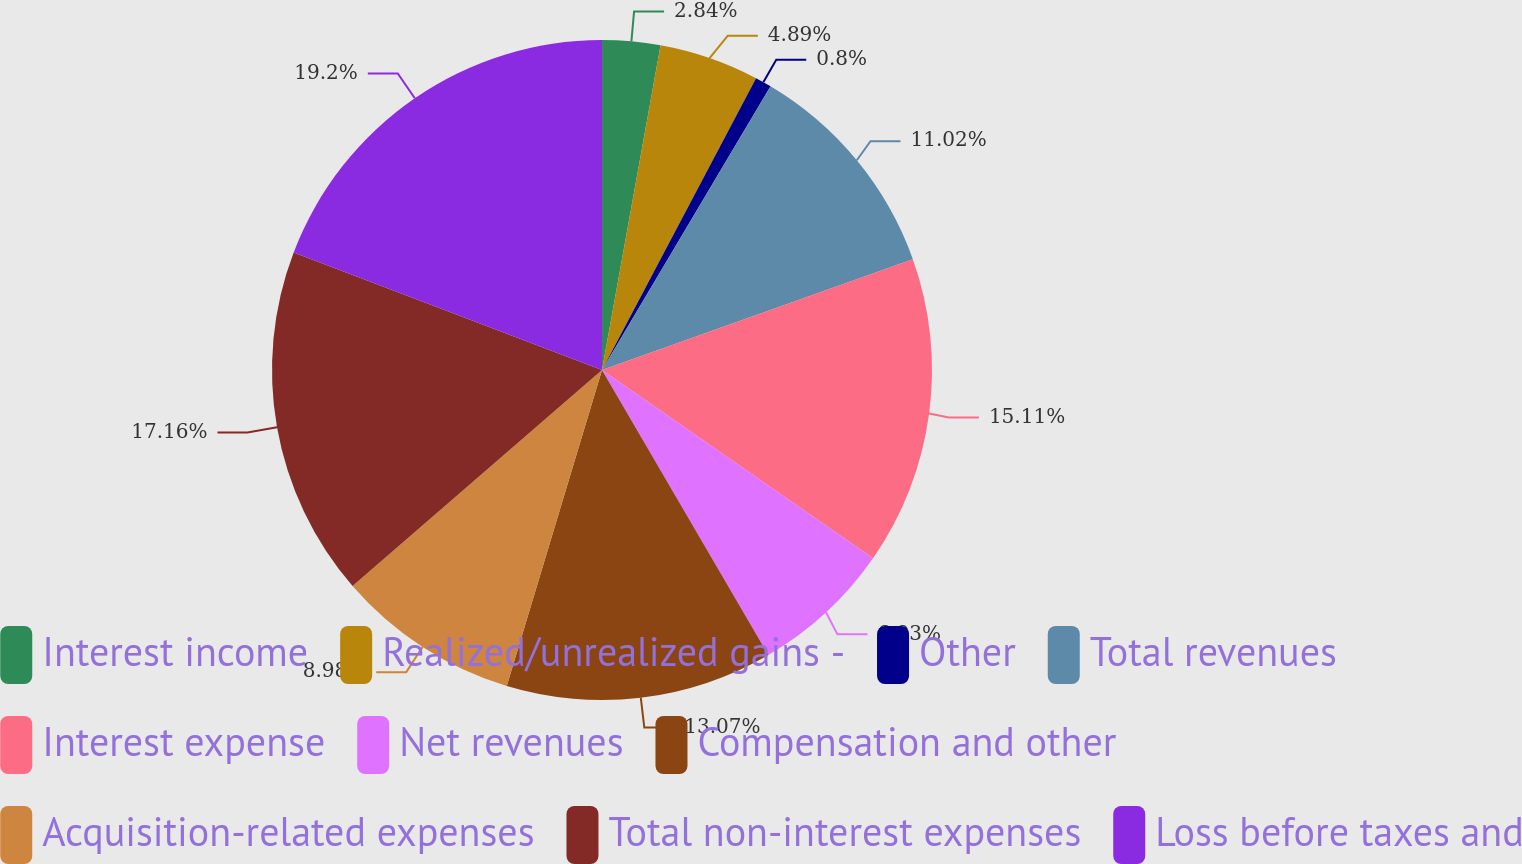Convert chart. <chart><loc_0><loc_0><loc_500><loc_500><pie_chart><fcel>Interest income<fcel>Realized/unrealized gains -<fcel>Other<fcel>Total revenues<fcel>Interest expense<fcel>Net revenues<fcel>Compensation and other<fcel>Acquisition-related expenses<fcel>Total non-interest expenses<fcel>Loss before taxes and<nl><fcel>2.84%<fcel>4.89%<fcel>0.8%<fcel>11.02%<fcel>15.11%<fcel>6.93%<fcel>13.07%<fcel>8.98%<fcel>17.16%<fcel>19.2%<nl></chart> 